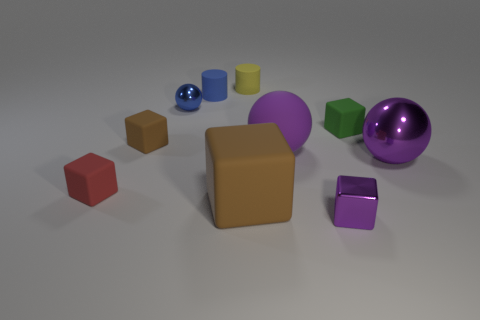Subtract all big balls. How many balls are left? 1 Subtract all yellow cylinders. How many cylinders are left? 1 Subtract all spheres. How many objects are left? 7 Subtract all gray cylinders. How many red balls are left? 0 Add 8 yellow things. How many yellow things exist? 9 Subtract 0 cyan cylinders. How many objects are left? 10 Subtract 2 cylinders. How many cylinders are left? 0 Subtract all blue cubes. Subtract all cyan balls. How many cubes are left? 5 Subtract all small yellow matte balls. Subtract all small blue balls. How many objects are left? 9 Add 7 red matte cubes. How many red matte cubes are left? 8 